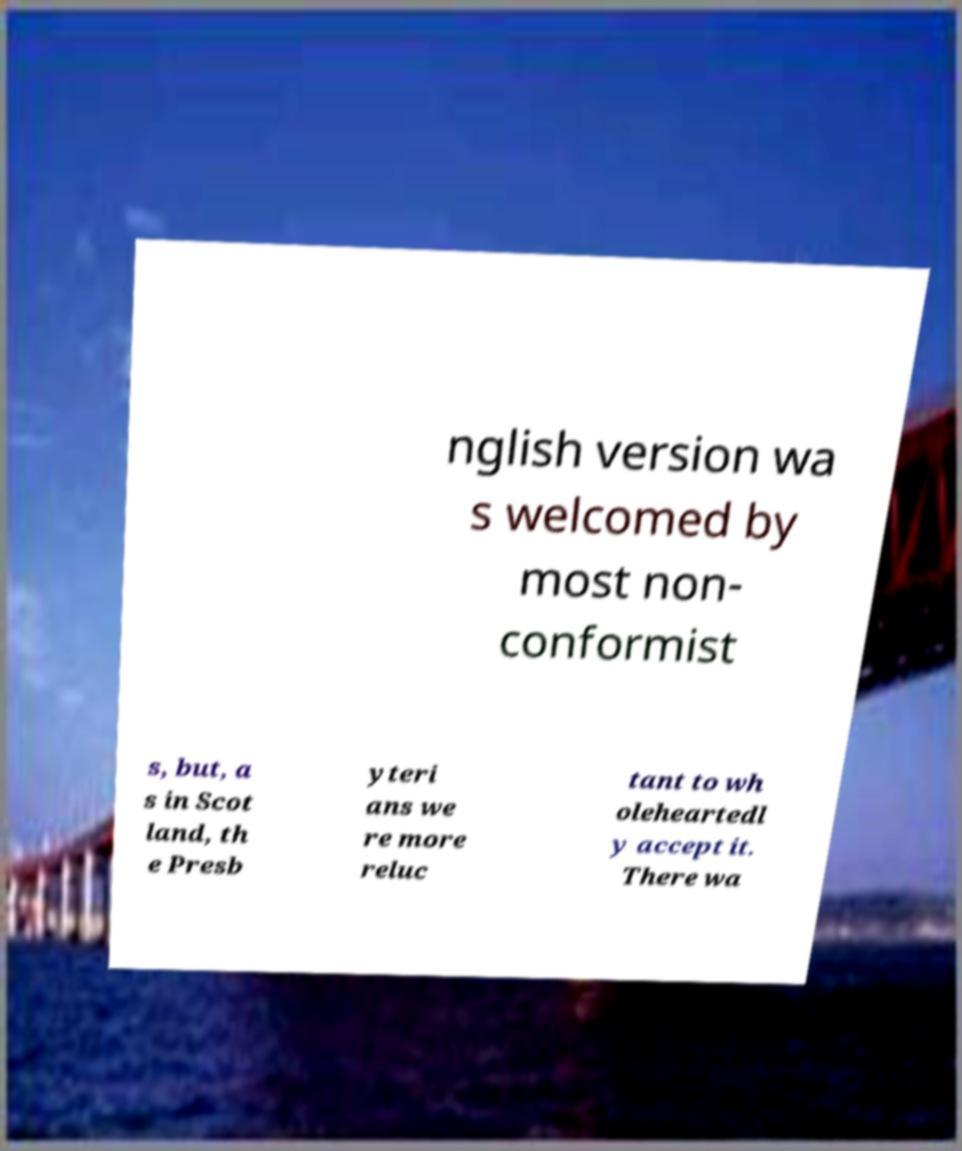Could you extract and type out the text from this image? nglish version wa s welcomed by most non- conformist s, but, a s in Scot land, th e Presb yteri ans we re more reluc tant to wh oleheartedl y accept it. There wa 